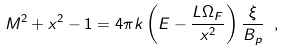Convert formula to latex. <formula><loc_0><loc_0><loc_500><loc_500>M ^ { 2 } + x ^ { 2 } - 1 = 4 \pi k \left ( E - \frac { L \Omega _ { F } } { x ^ { 2 } } \right ) \frac { \xi } { B _ { p } } \ ,</formula> 